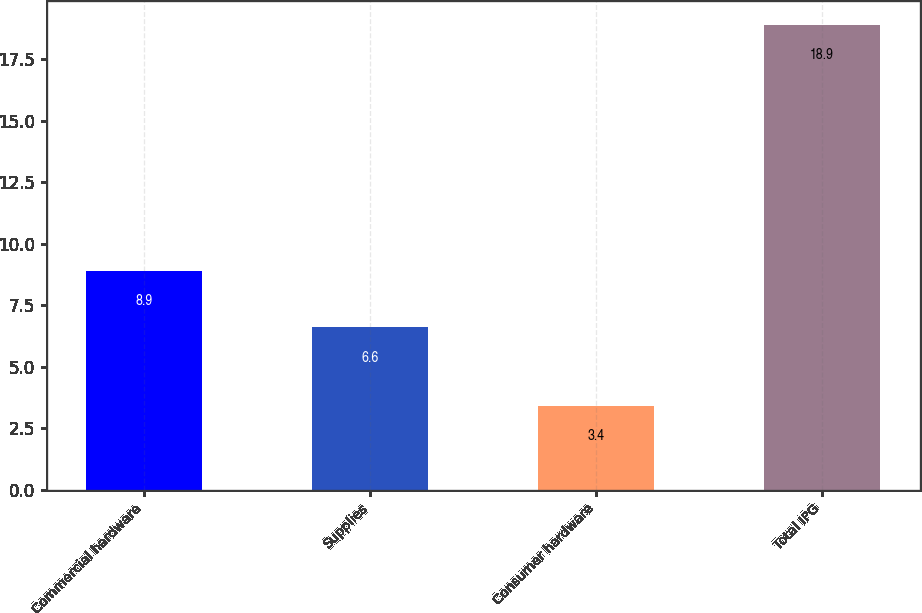Convert chart to OTSL. <chart><loc_0><loc_0><loc_500><loc_500><bar_chart><fcel>Commercial hardware<fcel>Supplies<fcel>Consumer hardware<fcel>Total IPG<nl><fcel>8.9<fcel>6.6<fcel>3.4<fcel>18.9<nl></chart> 